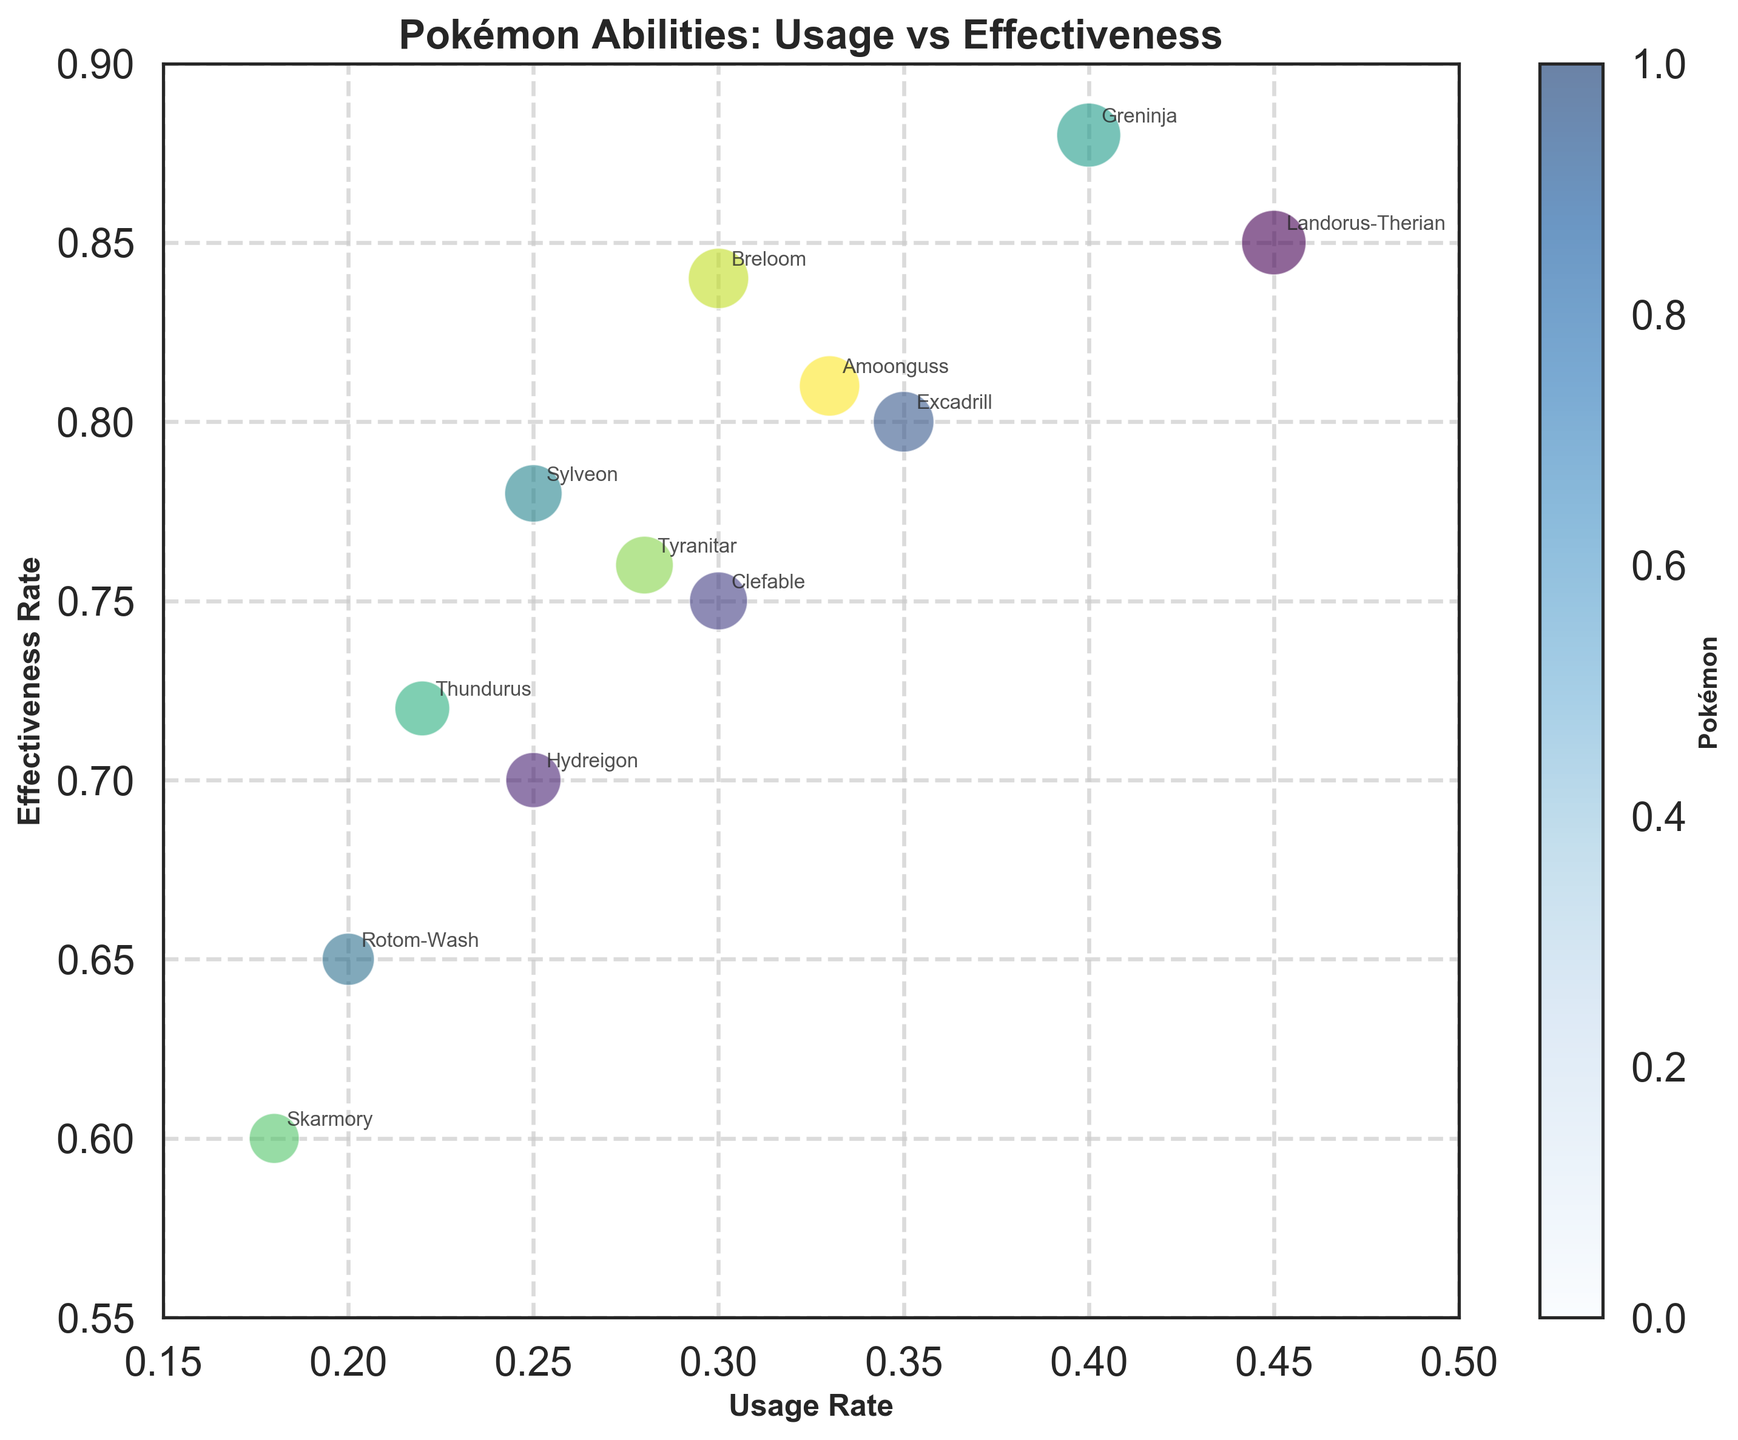what is the highest effectiveness rate listed? To find the highest effectiveness rate, look at the y-axis where effectiveness rates are plotted and identify the highest point on that axis which is reached in the chart.
Answer: 0.88 What is the title of the figure? The title is usually located at the top of the figure and gives an overview of what the plot is displaying.
Answer: Pokémon Abilities: Usage vs Effectiveness which Pokémon is closest to the center of the plot area? To find the Pokémon closest to the center, identify the data point nearest to the middle of the x and y axis ranges.
Answer: Clefable What is the usage rate for Greninja? Find Greninja on the plot by looking at the labels and trace vertically down to the x-axis to determine the usage rate.
Answer: 0.40 What is the range of usage rates on the x-axis? To determine the range, find the lowest and highest values marked on the x-axis and calculate the difference.
Answer: 0.15 to 0.5 Which Pokémon has the largest bubble? The size of the bubble represents the combined value of both usage rate and effectiveness rate; therefore, identify the largest bubble visually on the chart.
Answer: Greninja Is there a Pokémon with both low usage and high effectiveness? If so, which one? Look for a bubble low on the x-axis (low usage rate) but high on the y-axis (high effectiveness rate). Make sure the respective bubble is at a lower x-value but a higher y-value.
Answer: Rotom-Wash Which Pokémon has an ability of 'Levitate' and what are their effectiveness rates? Locate the Pokémon with 'Levitate' from the annotation and check their respective effectiveness rates on the y-axis.
Answer: Hydreigon (0.70), Rotom-Wash (0.65) How does the effectiveness rate of 'Intimidate' compare to 'Sturdy'? Find the effectiveness rates for both 'Intimidate' and 'Sturdy' by checking respective points on the y-axis and compare them.
Answer: Intimidate is higher Which ability is more commonly used, 'Magic Guard' or 'Sand Stream'? Compare the x-axis (usage rate) values for the abilities 'Magic Guard' and 'Sand Stream' to see which is higher.
Answer: Magic Guard 